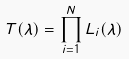Convert formula to latex. <formula><loc_0><loc_0><loc_500><loc_500>T ( \lambda ) = \prod _ { i = 1 } ^ { N } L _ { i } ( \lambda )</formula> 